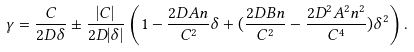Convert formula to latex. <formula><loc_0><loc_0><loc_500><loc_500>\gamma = \frac { C } { 2 D \delta } \pm \frac { | C | } { 2 D | \delta | } \left ( 1 - \frac { 2 D A n } { C ^ { 2 } } \delta + ( \frac { 2 D B n } { C ^ { 2 } } - \frac { 2 D ^ { 2 } A ^ { 2 } n ^ { 2 } } { C ^ { 4 } } ) \delta ^ { 2 } \right ) .</formula> 